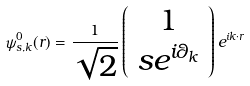<formula> <loc_0><loc_0><loc_500><loc_500>\psi ^ { 0 } _ { s , { k } } ( { r } ) = \frac { 1 } { \sqrt { 2 } } \left ( \begin{array} { c } 1 \\ s e ^ { i \theta _ { k } } \end{array} \right ) e ^ { i { k } \cdot { r } }</formula> 